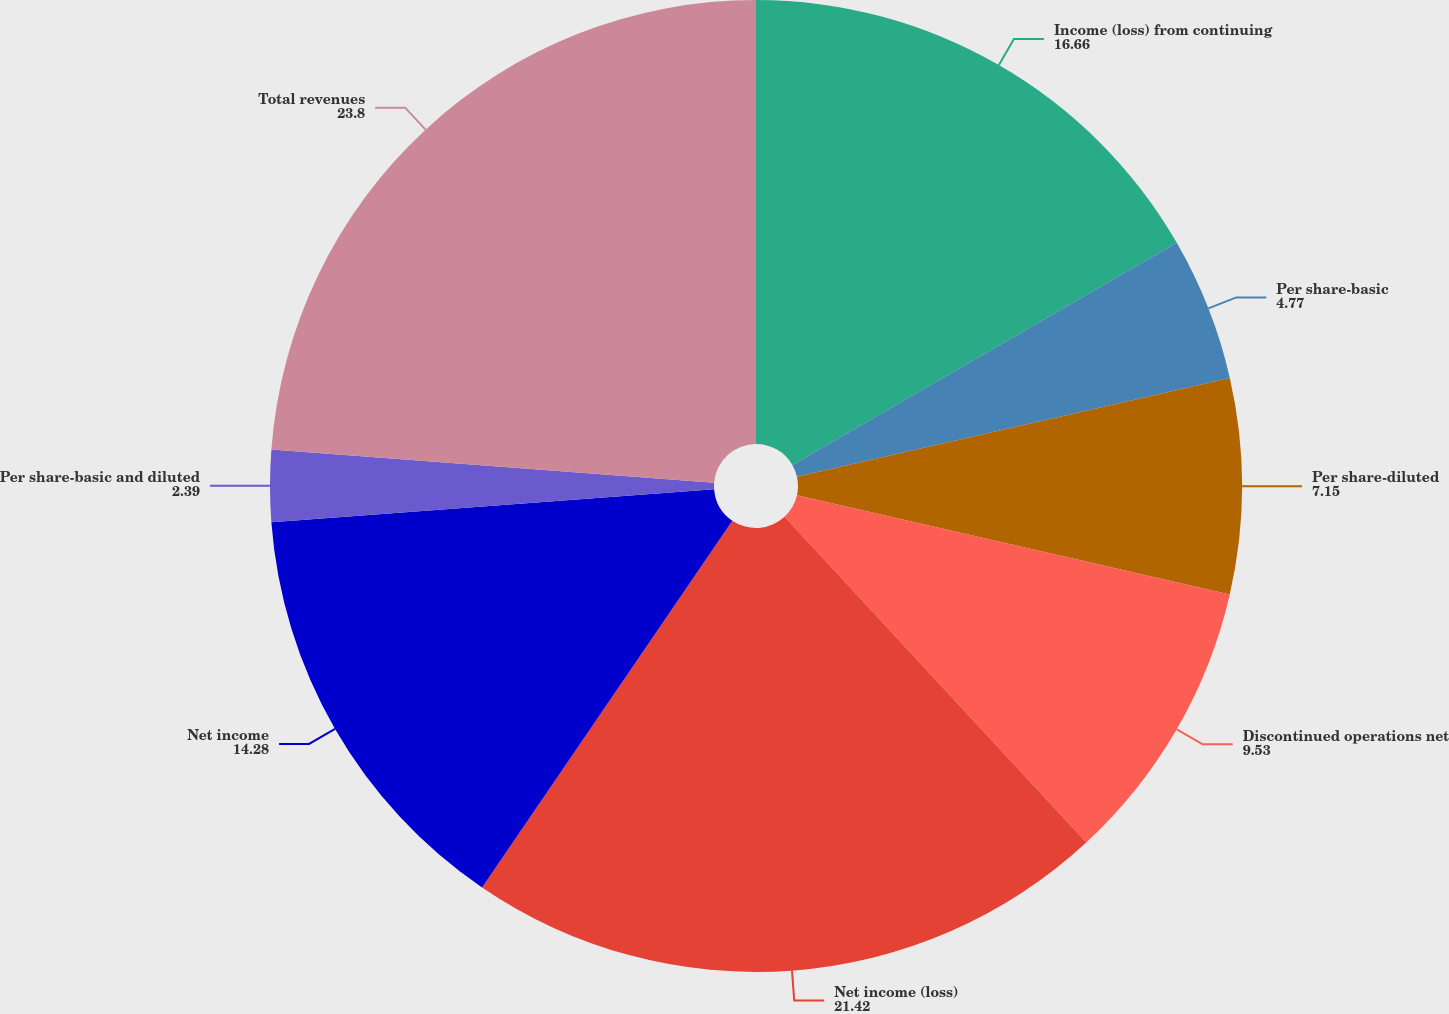Convert chart to OTSL. <chart><loc_0><loc_0><loc_500><loc_500><pie_chart><fcel>Income (loss) from continuing<fcel>Per share-basic<fcel>Per share-diluted<fcel>Discontinued operations net<fcel>Net income (loss)<fcel>Net income<fcel>Per share-basic and diluted<fcel>Total revenues<nl><fcel>16.66%<fcel>4.77%<fcel>7.15%<fcel>9.53%<fcel>21.42%<fcel>14.28%<fcel>2.39%<fcel>23.8%<nl></chart> 